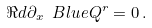Convert formula to latex. <formula><loc_0><loc_0><loc_500><loc_500>\Re d { \partial _ { x } } \ B l u e { Q ^ { r } } = 0 \, .</formula> 